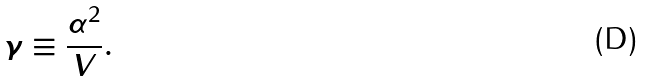Convert formula to latex. <formula><loc_0><loc_0><loc_500><loc_500>\gamma \equiv \frac { \alpha ^ { 2 } } { V } .</formula> 